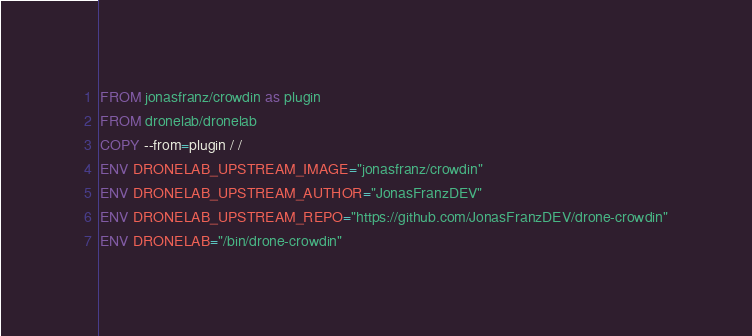Convert code to text. <code><loc_0><loc_0><loc_500><loc_500><_Dockerfile_>FROM jonasfranz/crowdin as plugin
FROM dronelab/dronelab
COPY --from=plugin / /
ENV DRONELAB_UPSTREAM_IMAGE="jonasfranz/crowdin"
ENV DRONELAB_UPSTREAM_AUTHOR="JonasFranzDEV"
ENV DRONELAB_UPSTREAM_REPO="https://github.com/JonasFranzDEV/drone-crowdin"
ENV DRONELAB="/bin/drone-crowdin"
</code> 